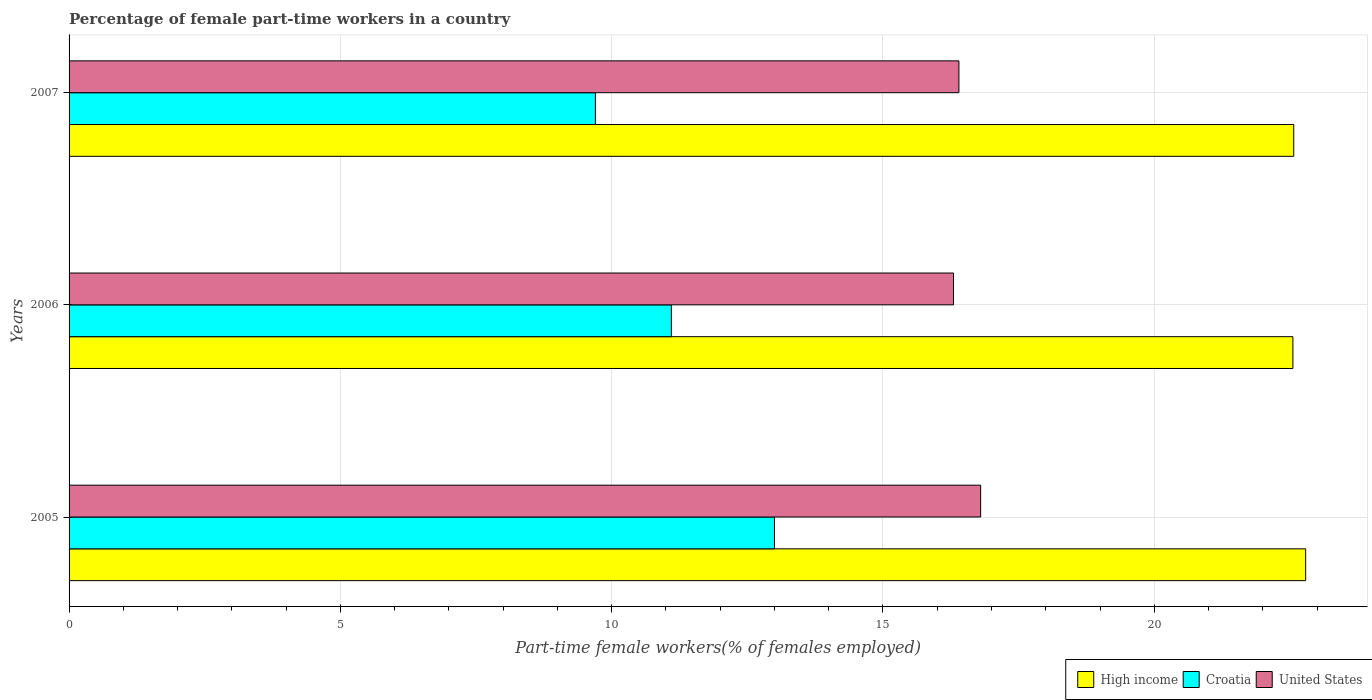How many different coloured bars are there?
Provide a succinct answer. 3. How many bars are there on the 3rd tick from the bottom?
Offer a very short reply. 3. What is the label of the 3rd group of bars from the top?
Offer a terse response. 2005. In how many cases, is the number of bars for a given year not equal to the number of legend labels?
Give a very brief answer. 0. What is the percentage of female part-time workers in High income in 2007?
Your response must be concise. 22.57. Across all years, what is the maximum percentage of female part-time workers in United States?
Ensure brevity in your answer.  16.8. Across all years, what is the minimum percentage of female part-time workers in Croatia?
Your answer should be very brief. 9.7. What is the total percentage of female part-time workers in High income in the graph?
Your response must be concise. 67.92. What is the difference between the percentage of female part-time workers in High income in 2005 and that in 2007?
Make the answer very short. 0.22. What is the difference between the percentage of female part-time workers in Croatia in 2006 and the percentage of female part-time workers in United States in 2007?
Make the answer very short. -5.3. What is the average percentage of female part-time workers in Croatia per year?
Offer a terse response. 11.27. In the year 2006, what is the difference between the percentage of female part-time workers in Croatia and percentage of female part-time workers in High income?
Your response must be concise. -11.45. What is the ratio of the percentage of female part-time workers in High income in 2005 to that in 2006?
Your response must be concise. 1.01. Is the percentage of female part-time workers in Croatia in 2006 less than that in 2007?
Provide a short and direct response. No. Is the difference between the percentage of female part-time workers in Croatia in 2006 and 2007 greater than the difference between the percentage of female part-time workers in High income in 2006 and 2007?
Offer a terse response. Yes. What is the difference between the highest and the second highest percentage of female part-time workers in United States?
Keep it short and to the point. 0.4. What is the difference between the highest and the lowest percentage of female part-time workers in Croatia?
Your answer should be compact. 3.3. In how many years, is the percentage of female part-time workers in United States greater than the average percentage of female part-time workers in United States taken over all years?
Provide a short and direct response. 1. What does the 1st bar from the top in 2006 represents?
Your answer should be very brief. United States. Are all the bars in the graph horizontal?
Provide a short and direct response. Yes. Are the values on the major ticks of X-axis written in scientific E-notation?
Offer a terse response. No. Does the graph contain any zero values?
Give a very brief answer. No. Does the graph contain grids?
Provide a succinct answer. Yes. Where does the legend appear in the graph?
Provide a short and direct response. Bottom right. How many legend labels are there?
Ensure brevity in your answer.  3. What is the title of the graph?
Provide a short and direct response. Percentage of female part-time workers in a country. What is the label or title of the X-axis?
Your response must be concise. Part-time female workers(% of females employed). What is the label or title of the Y-axis?
Offer a terse response. Years. What is the Part-time female workers(% of females employed) of High income in 2005?
Ensure brevity in your answer.  22.79. What is the Part-time female workers(% of females employed) in United States in 2005?
Provide a succinct answer. 16.8. What is the Part-time female workers(% of females employed) in High income in 2006?
Your answer should be very brief. 22.55. What is the Part-time female workers(% of females employed) of Croatia in 2006?
Give a very brief answer. 11.1. What is the Part-time female workers(% of females employed) of United States in 2006?
Ensure brevity in your answer.  16.3. What is the Part-time female workers(% of females employed) of High income in 2007?
Offer a very short reply. 22.57. What is the Part-time female workers(% of females employed) in Croatia in 2007?
Offer a terse response. 9.7. What is the Part-time female workers(% of females employed) in United States in 2007?
Your response must be concise. 16.4. Across all years, what is the maximum Part-time female workers(% of females employed) of High income?
Make the answer very short. 22.79. Across all years, what is the maximum Part-time female workers(% of females employed) in United States?
Offer a terse response. 16.8. Across all years, what is the minimum Part-time female workers(% of females employed) in High income?
Offer a terse response. 22.55. Across all years, what is the minimum Part-time female workers(% of females employed) in Croatia?
Provide a succinct answer. 9.7. Across all years, what is the minimum Part-time female workers(% of females employed) of United States?
Ensure brevity in your answer.  16.3. What is the total Part-time female workers(% of females employed) in High income in the graph?
Make the answer very short. 67.92. What is the total Part-time female workers(% of females employed) in Croatia in the graph?
Offer a terse response. 33.8. What is the total Part-time female workers(% of females employed) of United States in the graph?
Offer a terse response. 49.5. What is the difference between the Part-time female workers(% of females employed) in High income in 2005 and that in 2006?
Ensure brevity in your answer.  0.24. What is the difference between the Part-time female workers(% of females employed) in United States in 2005 and that in 2006?
Provide a short and direct response. 0.5. What is the difference between the Part-time female workers(% of females employed) of High income in 2005 and that in 2007?
Give a very brief answer. 0.22. What is the difference between the Part-time female workers(% of females employed) in United States in 2005 and that in 2007?
Your answer should be compact. 0.4. What is the difference between the Part-time female workers(% of females employed) in High income in 2006 and that in 2007?
Your answer should be very brief. -0.02. What is the difference between the Part-time female workers(% of females employed) of High income in 2005 and the Part-time female workers(% of females employed) of Croatia in 2006?
Offer a terse response. 11.69. What is the difference between the Part-time female workers(% of females employed) of High income in 2005 and the Part-time female workers(% of females employed) of United States in 2006?
Ensure brevity in your answer.  6.49. What is the difference between the Part-time female workers(% of females employed) of Croatia in 2005 and the Part-time female workers(% of females employed) of United States in 2006?
Offer a very short reply. -3.3. What is the difference between the Part-time female workers(% of females employed) of High income in 2005 and the Part-time female workers(% of females employed) of Croatia in 2007?
Provide a short and direct response. 13.09. What is the difference between the Part-time female workers(% of females employed) in High income in 2005 and the Part-time female workers(% of females employed) in United States in 2007?
Offer a terse response. 6.39. What is the difference between the Part-time female workers(% of females employed) in Croatia in 2005 and the Part-time female workers(% of females employed) in United States in 2007?
Ensure brevity in your answer.  -3.4. What is the difference between the Part-time female workers(% of females employed) of High income in 2006 and the Part-time female workers(% of females employed) of Croatia in 2007?
Make the answer very short. 12.85. What is the difference between the Part-time female workers(% of females employed) in High income in 2006 and the Part-time female workers(% of females employed) in United States in 2007?
Your answer should be compact. 6.15. What is the difference between the Part-time female workers(% of females employed) of Croatia in 2006 and the Part-time female workers(% of females employed) of United States in 2007?
Offer a terse response. -5.3. What is the average Part-time female workers(% of females employed) of High income per year?
Ensure brevity in your answer.  22.64. What is the average Part-time female workers(% of females employed) of Croatia per year?
Ensure brevity in your answer.  11.27. In the year 2005, what is the difference between the Part-time female workers(% of females employed) of High income and Part-time female workers(% of females employed) of Croatia?
Give a very brief answer. 9.79. In the year 2005, what is the difference between the Part-time female workers(% of females employed) in High income and Part-time female workers(% of females employed) in United States?
Provide a succinct answer. 5.99. In the year 2005, what is the difference between the Part-time female workers(% of females employed) in Croatia and Part-time female workers(% of females employed) in United States?
Make the answer very short. -3.8. In the year 2006, what is the difference between the Part-time female workers(% of females employed) of High income and Part-time female workers(% of females employed) of Croatia?
Offer a terse response. 11.45. In the year 2006, what is the difference between the Part-time female workers(% of females employed) in High income and Part-time female workers(% of females employed) in United States?
Your answer should be compact. 6.25. In the year 2006, what is the difference between the Part-time female workers(% of females employed) of Croatia and Part-time female workers(% of females employed) of United States?
Give a very brief answer. -5.2. In the year 2007, what is the difference between the Part-time female workers(% of females employed) of High income and Part-time female workers(% of females employed) of Croatia?
Your answer should be compact. 12.87. In the year 2007, what is the difference between the Part-time female workers(% of females employed) of High income and Part-time female workers(% of females employed) of United States?
Your answer should be very brief. 6.17. What is the ratio of the Part-time female workers(% of females employed) of High income in 2005 to that in 2006?
Provide a short and direct response. 1.01. What is the ratio of the Part-time female workers(% of females employed) in Croatia in 2005 to that in 2006?
Your answer should be compact. 1.17. What is the ratio of the Part-time female workers(% of females employed) in United States in 2005 to that in 2006?
Provide a succinct answer. 1.03. What is the ratio of the Part-time female workers(% of females employed) of High income in 2005 to that in 2007?
Keep it short and to the point. 1.01. What is the ratio of the Part-time female workers(% of females employed) of Croatia in 2005 to that in 2007?
Ensure brevity in your answer.  1.34. What is the ratio of the Part-time female workers(% of females employed) in United States in 2005 to that in 2007?
Your answer should be compact. 1.02. What is the ratio of the Part-time female workers(% of females employed) in Croatia in 2006 to that in 2007?
Your answer should be compact. 1.14. What is the ratio of the Part-time female workers(% of females employed) in United States in 2006 to that in 2007?
Keep it short and to the point. 0.99. What is the difference between the highest and the second highest Part-time female workers(% of females employed) of High income?
Your answer should be compact. 0.22. What is the difference between the highest and the second highest Part-time female workers(% of females employed) of Croatia?
Ensure brevity in your answer.  1.9. What is the difference between the highest and the lowest Part-time female workers(% of females employed) of High income?
Your answer should be compact. 0.24. What is the difference between the highest and the lowest Part-time female workers(% of females employed) in United States?
Give a very brief answer. 0.5. 